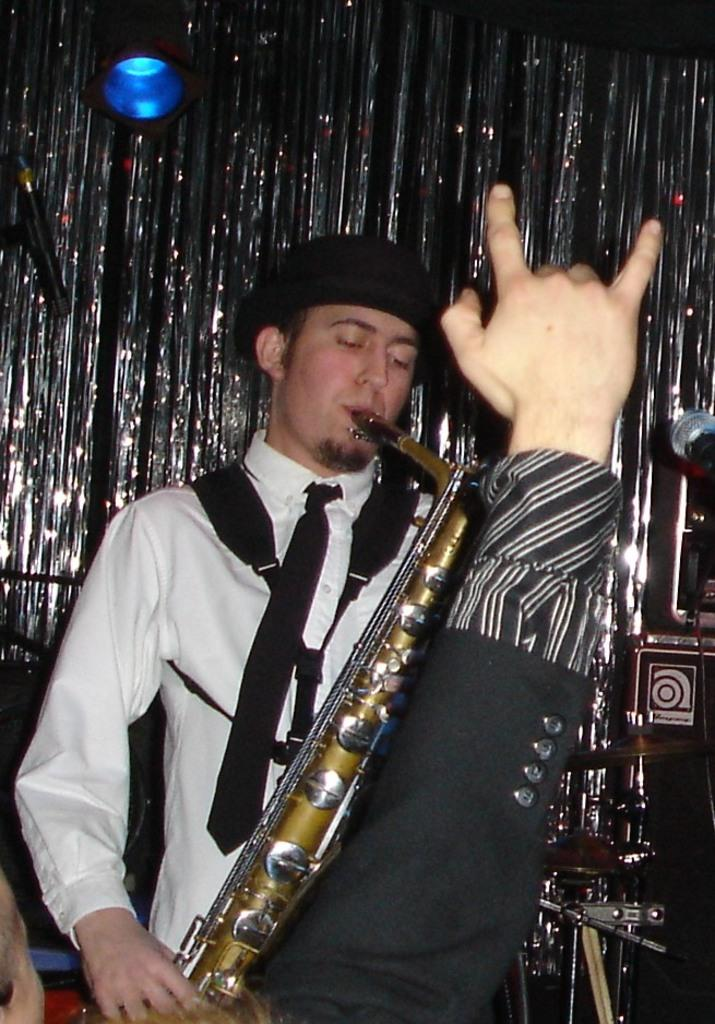What is the man in the image doing? The man in the image is playing a trumpet. Can you describe any other elements in the foreground of the image? Yes, there is a hand of another man in the foreground area of the image. What can be seen in the background of the image? In the background, there is a lamp, glitter curtains, and a microphone. What type of vacation is the man planning with his father in the image? There is no mention of a vacation or father in the image; it features a man playing a trumpet and other elements in the background. 